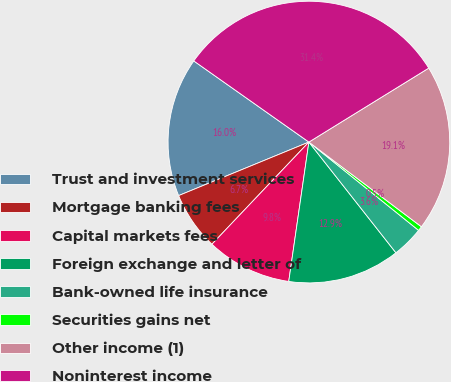Convert chart to OTSL. <chart><loc_0><loc_0><loc_500><loc_500><pie_chart><fcel>Trust and investment services<fcel>Mortgage banking fees<fcel>Capital markets fees<fcel>Foreign exchange and letter of<fcel>Bank-owned life insurance<fcel>Securities gains net<fcel>Other income (1)<fcel>Noninterest income<nl><fcel>15.98%<fcel>6.71%<fcel>9.8%<fcel>12.89%<fcel>3.61%<fcel>0.52%<fcel>19.07%<fcel>31.43%<nl></chart> 